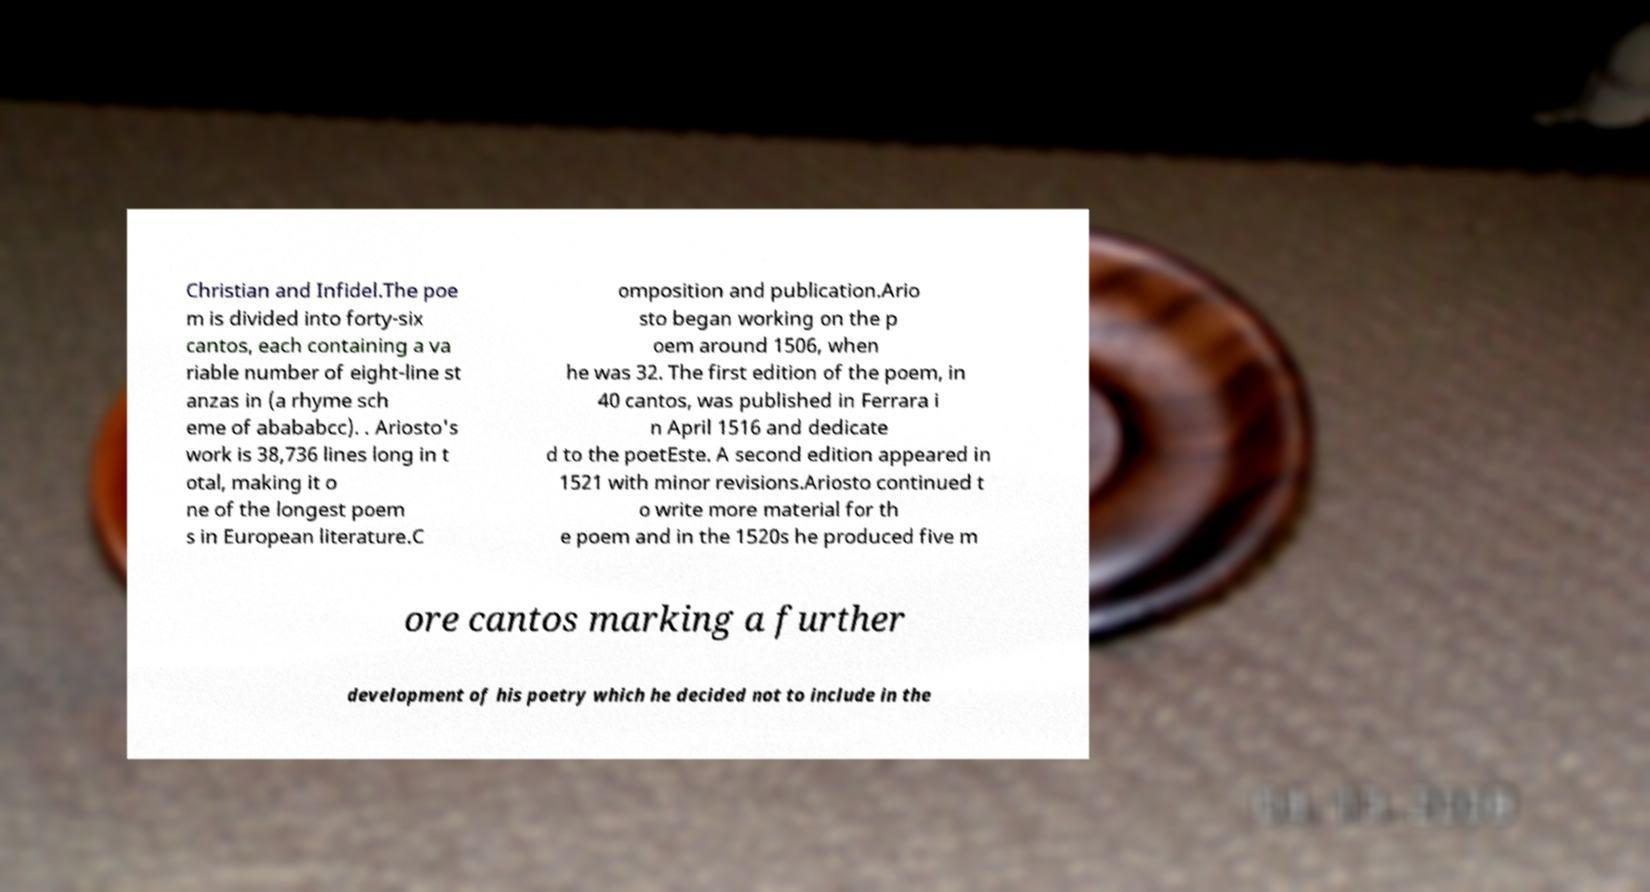Can you accurately transcribe the text from the provided image for me? Christian and Infidel.The poe m is divided into forty-six cantos, each containing a va riable number of eight-line st anzas in (a rhyme sch eme of abababcc). . Ariosto's work is 38,736 lines long in t otal, making it o ne of the longest poem s in European literature.C omposition and publication.Ario sto began working on the p oem around 1506, when he was 32. The first edition of the poem, in 40 cantos, was published in Ferrara i n April 1516 and dedicate d to the poetEste. A second edition appeared in 1521 with minor revisions.Ariosto continued t o write more material for th e poem and in the 1520s he produced five m ore cantos marking a further development of his poetry which he decided not to include in the 